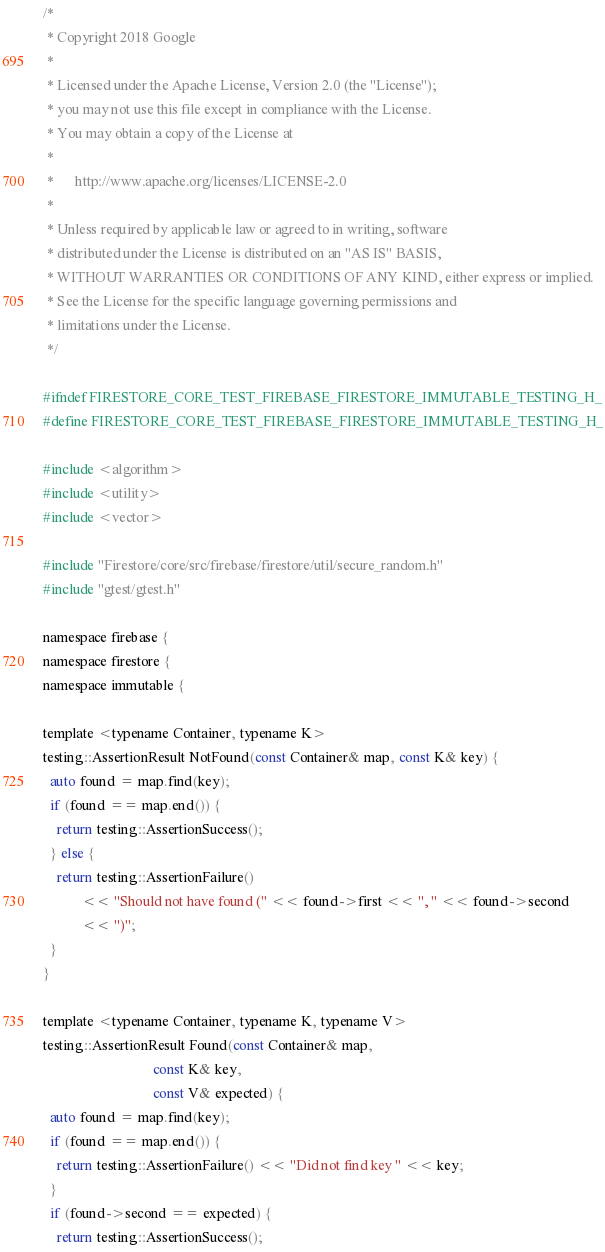<code> <loc_0><loc_0><loc_500><loc_500><_C_>/*
 * Copyright 2018 Google
 *
 * Licensed under the Apache License, Version 2.0 (the "License");
 * you may not use this file except in compliance with the License.
 * You may obtain a copy of the License at
 *
 *      http://www.apache.org/licenses/LICENSE-2.0
 *
 * Unless required by applicable law or agreed to in writing, software
 * distributed under the License is distributed on an "AS IS" BASIS,
 * WITHOUT WARRANTIES OR CONDITIONS OF ANY KIND, either express or implied.
 * See the License for the specific language governing permissions and
 * limitations under the License.
 */

#ifndef FIRESTORE_CORE_TEST_FIREBASE_FIRESTORE_IMMUTABLE_TESTING_H_
#define FIRESTORE_CORE_TEST_FIREBASE_FIRESTORE_IMMUTABLE_TESTING_H_

#include <algorithm>
#include <utility>
#include <vector>

#include "Firestore/core/src/firebase/firestore/util/secure_random.h"
#include "gtest/gtest.h"

namespace firebase {
namespace firestore {
namespace immutable {

template <typename Container, typename K>
testing::AssertionResult NotFound(const Container& map, const K& key) {
  auto found = map.find(key);
  if (found == map.end()) {
    return testing::AssertionSuccess();
  } else {
    return testing::AssertionFailure()
           << "Should not have found (" << found->first << ", " << found->second
           << ")";
  }
}

template <typename Container, typename K, typename V>
testing::AssertionResult Found(const Container& map,
                               const K& key,
                               const V& expected) {
  auto found = map.find(key);
  if (found == map.end()) {
    return testing::AssertionFailure() << "Did not find key " << key;
  }
  if (found->second == expected) {
    return testing::AssertionSuccess();</code> 